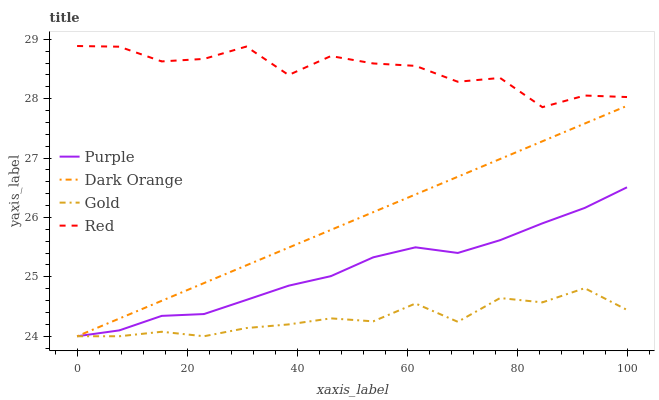Does Gold have the minimum area under the curve?
Answer yes or no. Yes. Does Red have the maximum area under the curve?
Answer yes or no. Yes. Does Dark Orange have the minimum area under the curve?
Answer yes or no. No. Does Dark Orange have the maximum area under the curve?
Answer yes or no. No. Is Dark Orange the smoothest?
Answer yes or no. Yes. Is Red the roughest?
Answer yes or no. Yes. Is Red the smoothest?
Answer yes or no. No. Is Dark Orange the roughest?
Answer yes or no. No. Does Red have the lowest value?
Answer yes or no. No. Does Red have the highest value?
Answer yes or no. Yes. Does Dark Orange have the highest value?
Answer yes or no. No. Is Gold less than Red?
Answer yes or no. Yes. Is Red greater than Purple?
Answer yes or no. Yes. Does Gold intersect Dark Orange?
Answer yes or no. Yes. Is Gold less than Dark Orange?
Answer yes or no. No. Is Gold greater than Dark Orange?
Answer yes or no. No. Does Gold intersect Red?
Answer yes or no. No. 